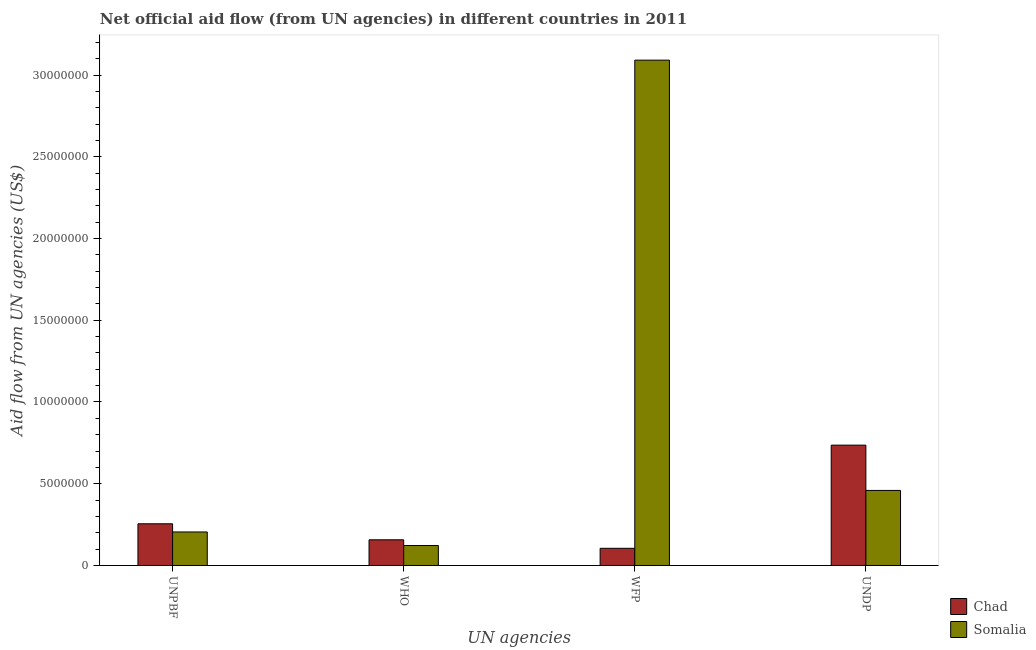How many different coloured bars are there?
Provide a short and direct response. 2. Are the number of bars on each tick of the X-axis equal?
Make the answer very short. Yes. How many bars are there on the 3rd tick from the left?
Offer a terse response. 2. How many bars are there on the 4th tick from the right?
Offer a very short reply. 2. What is the label of the 2nd group of bars from the left?
Your response must be concise. WHO. What is the amount of aid given by undp in Somalia?
Give a very brief answer. 4.59e+06. Across all countries, what is the maximum amount of aid given by undp?
Offer a terse response. 7.36e+06. Across all countries, what is the minimum amount of aid given by wfp?
Your answer should be very brief. 1.05e+06. In which country was the amount of aid given by wfp maximum?
Make the answer very short. Somalia. In which country was the amount of aid given by who minimum?
Provide a short and direct response. Somalia. What is the total amount of aid given by undp in the graph?
Your answer should be compact. 1.20e+07. What is the difference between the amount of aid given by unpbf in Somalia and that in Chad?
Make the answer very short. -5.00e+05. What is the difference between the amount of aid given by undp in Chad and the amount of aid given by unpbf in Somalia?
Ensure brevity in your answer.  5.31e+06. What is the average amount of aid given by wfp per country?
Your response must be concise. 1.60e+07. What is the difference between the amount of aid given by unpbf and amount of aid given by undp in Chad?
Keep it short and to the point. -4.81e+06. What is the ratio of the amount of aid given by who in Chad to that in Somalia?
Your response must be concise. 1.29. Is the difference between the amount of aid given by undp in Chad and Somalia greater than the difference between the amount of aid given by who in Chad and Somalia?
Make the answer very short. Yes. What is the difference between the highest and the second highest amount of aid given by unpbf?
Offer a terse response. 5.00e+05. What is the difference between the highest and the lowest amount of aid given by who?
Your response must be concise. 3.50e+05. Is the sum of the amount of aid given by wfp in Somalia and Chad greater than the maximum amount of aid given by undp across all countries?
Ensure brevity in your answer.  Yes. Is it the case that in every country, the sum of the amount of aid given by undp and amount of aid given by unpbf is greater than the sum of amount of aid given by wfp and amount of aid given by who?
Your answer should be compact. Yes. What does the 1st bar from the left in WFP represents?
Provide a succinct answer. Chad. What does the 1st bar from the right in UNPBF represents?
Provide a succinct answer. Somalia. Is it the case that in every country, the sum of the amount of aid given by unpbf and amount of aid given by who is greater than the amount of aid given by wfp?
Ensure brevity in your answer.  No. Are the values on the major ticks of Y-axis written in scientific E-notation?
Your answer should be very brief. No. Where does the legend appear in the graph?
Your answer should be compact. Bottom right. How many legend labels are there?
Provide a succinct answer. 2. What is the title of the graph?
Offer a very short reply. Net official aid flow (from UN agencies) in different countries in 2011. What is the label or title of the X-axis?
Keep it short and to the point. UN agencies. What is the label or title of the Y-axis?
Give a very brief answer. Aid flow from UN agencies (US$). What is the Aid flow from UN agencies (US$) of Chad in UNPBF?
Your answer should be very brief. 2.55e+06. What is the Aid flow from UN agencies (US$) of Somalia in UNPBF?
Your response must be concise. 2.05e+06. What is the Aid flow from UN agencies (US$) in Chad in WHO?
Make the answer very short. 1.57e+06. What is the Aid flow from UN agencies (US$) in Somalia in WHO?
Offer a very short reply. 1.22e+06. What is the Aid flow from UN agencies (US$) in Chad in WFP?
Ensure brevity in your answer.  1.05e+06. What is the Aid flow from UN agencies (US$) in Somalia in WFP?
Make the answer very short. 3.09e+07. What is the Aid flow from UN agencies (US$) in Chad in UNDP?
Your response must be concise. 7.36e+06. What is the Aid flow from UN agencies (US$) in Somalia in UNDP?
Your response must be concise. 4.59e+06. Across all UN agencies, what is the maximum Aid flow from UN agencies (US$) in Chad?
Offer a very short reply. 7.36e+06. Across all UN agencies, what is the maximum Aid flow from UN agencies (US$) of Somalia?
Keep it short and to the point. 3.09e+07. Across all UN agencies, what is the minimum Aid flow from UN agencies (US$) of Chad?
Your answer should be very brief. 1.05e+06. Across all UN agencies, what is the minimum Aid flow from UN agencies (US$) of Somalia?
Provide a short and direct response. 1.22e+06. What is the total Aid flow from UN agencies (US$) in Chad in the graph?
Give a very brief answer. 1.25e+07. What is the total Aid flow from UN agencies (US$) of Somalia in the graph?
Offer a terse response. 3.88e+07. What is the difference between the Aid flow from UN agencies (US$) in Chad in UNPBF and that in WHO?
Offer a very short reply. 9.80e+05. What is the difference between the Aid flow from UN agencies (US$) of Somalia in UNPBF and that in WHO?
Provide a short and direct response. 8.30e+05. What is the difference between the Aid flow from UN agencies (US$) of Chad in UNPBF and that in WFP?
Give a very brief answer. 1.50e+06. What is the difference between the Aid flow from UN agencies (US$) in Somalia in UNPBF and that in WFP?
Provide a succinct answer. -2.89e+07. What is the difference between the Aid flow from UN agencies (US$) of Chad in UNPBF and that in UNDP?
Provide a succinct answer. -4.81e+06. What is the difference between the Aid flow from UN agencies (US$) of Somalia in UNPBF and that in UNDP?
Make the answer very short. -2.54e+06. What is the difference between the Aid flow from UN agencies (US$) of Chad in WHO and that in WFP?
Provide a short and direct response. 5.20e+05. What is the difference between the Aid flow from UN agencies (US$) in Somalia in WHO and that in WFP?
Ensure brevity in your answer.  -2.97e+07. What is the difference between the Aid flow from UN agencies (US$) of Chad in WHO and that in UNDP?
Provide a succinct answer. -5.79e+06. What is the difference between the Aid flow from UN agencies (US$) in Somalia in WHO and that in UNDP?
Offer a very short reply. -3.37e+06. What is the difference between the Aid flow from UN agencies (US$) of Chad in WFP and that in UNDP?
Provide a short and direct response. -6.31e+06. What is the difference between the Aid flow from UN agencies (US$) in Somalia in WFP and that in UNDP?
Give a very brief answer. 2.63e+07. What is the difference between the Aid flow from UN agencies (US$) in Chad in UNPBF and the Aid flow from UN agencies (US$) in Somalia in WHO?
Your answer should be very brief. 1.33e+06. What is the difference between the Aid flow from UN agencies (US$) of Chad in UNPBF and the Aid flow from UN agencies (US$) of Somalia in WFP?
Provide a succinct answer. -2.84e+07. What is the difference between the Aid flow from UN agencies (US$) in Chad in UNPBF and the Aid flow from UN agencies (US$) in Somalia in UNDP?
Your answer should be very brief. -2.04e+06. What is the difference between the Aid flow from UN agencies (US$) of Chad in WHO and the Aid flow from UN agencies (US$) of Somalia in WFP?
Provide a short and direct response. -2.93e+07. What is the difference between the Aid flow from UN agencies (US$) in Chad in WHO and the Aid flow from UN agencies (US$) in Somalia in UNDP?
Give a very brief answer. -3.02e+06. What is the difference between the Aid flow from UN agencies (US$) of Chad in WFP and the Aid flow from UN agencies (US$) of Somalia in UNDP?
Offer a very short reply. -3.54e+06. What is the average Aid flow from UN agencies (US$) of Chad per UN agencies?
Offer a very short reply. 3.13e+06. What is the average Aid flow from UN agencies (US$) of Somalia per UN agencies?
Provide a short and direct response. 9.69e+06. What is the difference between the Aid flow from UN agencies (US$) in Chad and Aid flow from UN agencies (US$) in Somalia in UNPBF?
Provide a short and direct response. 5.00e+05. What is the difference between the Aid flow from UN agencies (US$) in Chad and Aid flow from UN agencies (US$) in Somalia in WFP?
Your answer should be compact. -2.99e+07. What is the difference between the Aid flow from UN agencies (US$) of Chad and Aid flow from UN agencies (US$) of Somalia in UNDP?
Keep it short and to the point. 2.77e+06. What is the ratio of the Aid flow from UN agencies (US$) in Chad in UNPBF to that in WHO?
Keep it short and to the point. 1.62. What is the ratio of the Aid flow from UN agencies (US$) in Somalia in UNPBF to that in WHO?
Offer a very short reply. 1.68. What is the ratio of the Aid flow from UN agencies (US$) in Chad in UNPBF to that in WFP?
Make the answer very short. 2.43. What is the ratio of the Aid flow from UN agencies (US$) in Somalia in UNPBF to that in WFP?
Your answer should be compact. 0.07. What is the ratio of the Aid flow from UN agencies (US$) in Chad in UNPBF to that in UNDP?
Provide a short and direct response. 0.35. What is the ratio of the Aid flow from UN agencies (US$) of Somalia in UNPBF to that in UNDP?
Offer a very short reply. 0.45. What is the ratio of the Aid flow from UN agencies (US$) of Chad in WHO to that in WFP?
Provide a succinct answer. 1.5. What is the ratio of the Aid flow from UN agencies (US$) in Somalia in WHO to that in WFP?
Your response must be concise. 0.04. What is the ratio of the Aid flow from UN agencies (US$) of Chad in WHO to that in UNDP?
Offer a terse response. 0.21. What is the ratio of the Aid flow from UN agencies (US$) of Somalia in WHO to that in UNDP?
Your answer should be very brief. 0.27. What is the ratio of the Aid flow from UN agencies (US$) in Chad in WFP to that in UNDP?
Make the answer very short. 0.14. What is the ratio of the Aid flow from UN agencies (US$) of Somalia in WFP to that in UNDP?
Offer a very short reply. 6.73. What is the difference between the highest and the second highest Aid flow from UN agencies (US$) of Chad?
Provide a succinct answer. 4.81e+06. What is the difference between the highest and the second highest Aid flow from UN agencies (US$) of Somalia?
Ensure brevity in your answer.  2.63e+07. What is the difference between the highest and the lowest Aid flow from UN agencies (US$) in Chad?
Offer a very short reply. 6.31e+06. What is the difference between the highest and the lowest Aid flow from UN agencies (US$) in Somalia?
Offer a very short reply. 2.97e+07. 